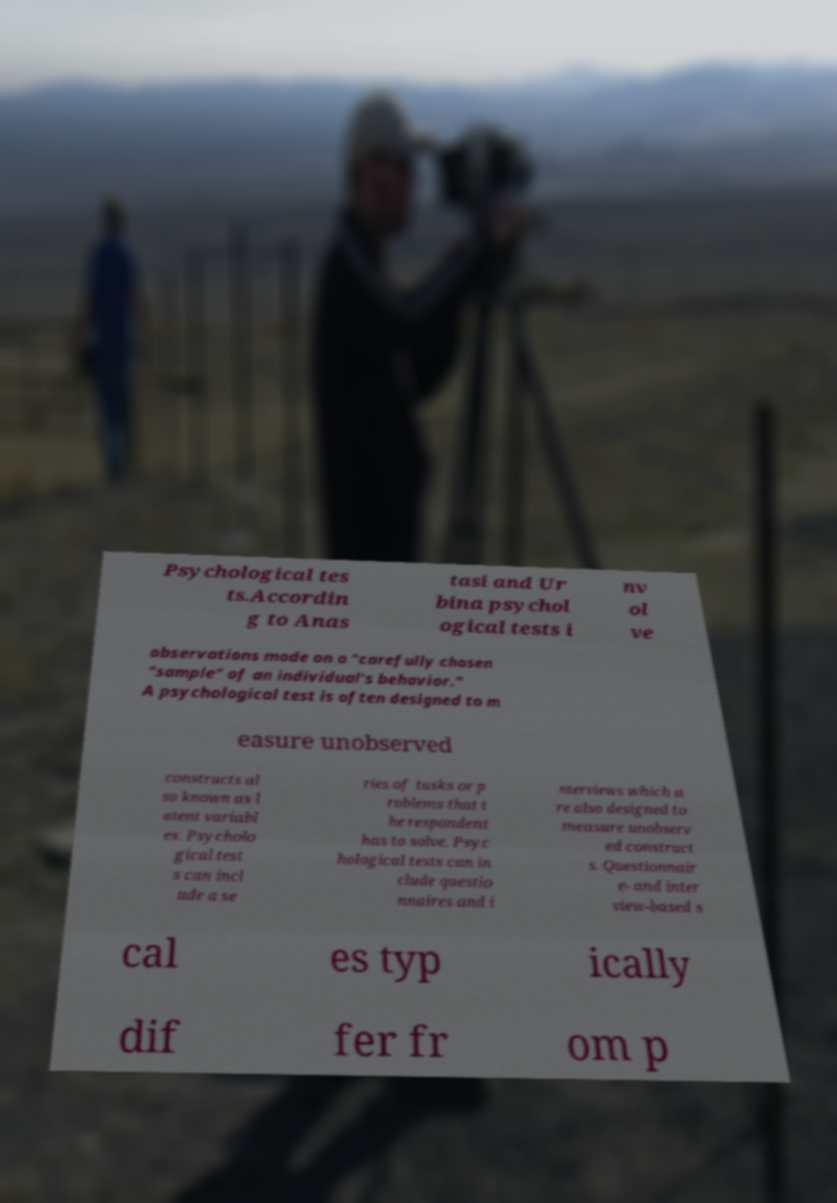Could you extract and type out the text from this image? Psychological tes ts.Accordin g to Anas tasi and Ur bina psychol ogical tests i nv ol ve observations made on a "carefully chosen "sample" of an individual's behavior." A psychological test is often designed to m easure unobserved constructs al so known as l atent variabl es. Psycholo gical test s can incl ude a se ries of tasks or p roblems that t he respondent has to solve. Psyc hological tests can in clude questio nnaires and i nterviews which a re also designed to measure unobserv ed construct s. Questionnair e- and inter view-based s cal es typ ically dif fer fr om p 